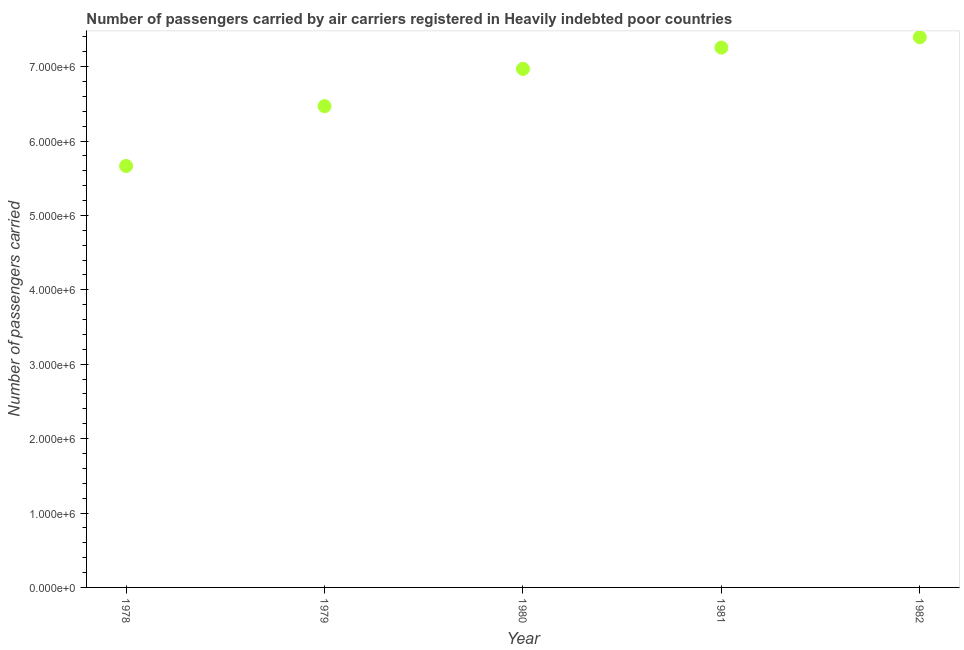What is the number of passengers carried in 1980?
Your response must be concise. 6.97e+06. Across all years, what is the maximum number of passengers carried?
Make the answer very short. 7.39e+06. Across all years, what is the minimum number of passengers carried?
Give a very brief answer. 5.66e+06. In which year was the number of passengers carried maximum?
Provide a short and direct response. 1982. In which year was the number of passengers carried minimum?
Keep it short and to the point. 1978. What is the sum of the number of passengers carried?
Offer a terse response. 3.38e+07. What is the difference between the number of passengers carried in 1980 and 1982?
Give a very brief answer. -4.25e+05. What is the average number of passengers carried per year?
Your answer should be compact. 6.75e+06. What is the median number of passengers carried?
Ensure brevity in your answer.  6.97e+06. Do a majority of the years between 1978 and 1979 (inclusive) have number of passengers carried greater than 800000 ?
Keep it short and to the point. Yes. What is the ratio of the number of passengers carried in 1978 to that in 1980?
Offer a very short reply. 0.81. Is the number of passengers carried in 1981 less than that in 1982?
Make the answer very short. Yes. Is the difference between the number of passengers carried in 1978 and 1981 greater than the difference between any two years?
Your answer should be very brief. No. What is the difference between the highest and the second highest number of passengers carried?
Make the answer very short. 1.39e+05. Is the sum of the number of passengers carried in 1978 and 1981 greater than the maximum number of passengers carried across all years?
Offer a terse response. Yes. What is the difference between the highest and the lowest number of passengers carried?
Keep it short and to the point. 1.73e+06. Does the number of passengers carried monotonically increase over the years?
Offer a very short reply. Yes. How many dotlines are there?
Give a very brief answer. 1. Does the graph contain grids?
Make the answer very short. No. What is the title of the graph?
Your response must be concise. Number of passengers carried by air carriers registered in Heavily indebted poor countries. What is the label or title of the Y-axis?
Your answer should be compact. Number of passengers carried. What is the Number of passengers carried in 1978?
Your answer should be compact. 5.66e+06. What is the Number of passengers carried in 1979?
Offer a very short reply. 6.47e+06. What is the Number of passengers carried in 1980?
Ensure brevity in your answer.  6.97e+06. What is the Number of passengers carried in 1981?
Give a very brief answer. 7.26e+06. What is the Number of passengers carried in 1982?
Your answer should be very brief. 7.39e+06. What is the difference between the Number of passengers carried in 1978 and 1979?
Provide a succinct answer. -8.04e+05. What is the difference between the Number of passengers carried in 1978 and 1980?
Ensure brevity in your answer.  -1.30e+06. What is the difference between the Number of passengers carried in 1978 and 1981?
Offer a terse response. -1.59e+06. What is the difference between the Number of passengers carried in 1978 and 1982?
Your response must be concise. -1.73e+06. What is the difference between the Number of passengers carried in 1979 and 1980?
Your response must be concise. -5.01e+05. What is the difference between the Number of passengers carried in 1979 and 1981?
Provide a short and direct response. -7.87e+05. What is the difference between the Number of passengers carried in 1979 and 1982?
Provide a short and direct response. -9.26e+05. What is the difference between the Number of passengers carried in 1980 and 1981?
Offer a very short reply. -2.86e+05. What is the difference between the Number of passengers carried in 1980 and 1982?
Your answer should be compact. -4.25e+05. What is the difference between the Number of passengers carried in 1981 and 1982?
Offer a terse response. -1.39e+05. What is the ratio of the Number of passengers carried in 1978 to that in 1979?
Your answer should be compact. 0.88. What is the ratio of the Number of passengers carried in 1978 to that in 1980?
Your answer should be compact. 0.81. What is the ratio of the Number of passengers carried in 1978 to that in 1981?
Offer a very short reply. 0.78. What is the ratio of the Number of passengers carried in 1978 to that in 1982?
Make the answer very short. 0.77. What is the ratio of the Number of passengers carried in 1979 to that in 1980?
Keep it short and to the point. 0.93. What is the ratio of the Number of passengers carried in 1979 to that in 1981?
Offer a terse response. 0.89. What is the ratio of the Number of passengers carried in 1979 to that in 1982?
Your answer should be very brief. 0.88. What is the ratio of the Number of passengers carried in 1980 to that in 1981?
Ensure brevity in your answer.  0.96. What is the ratio of the Number of passengers carried in 1980 to that in 1982?
Provide a short and direct response. 0.94. What is the ratio of the Number of passengers carried in 1981 to that in 1982?
Your answer should be compact. 0.98. 